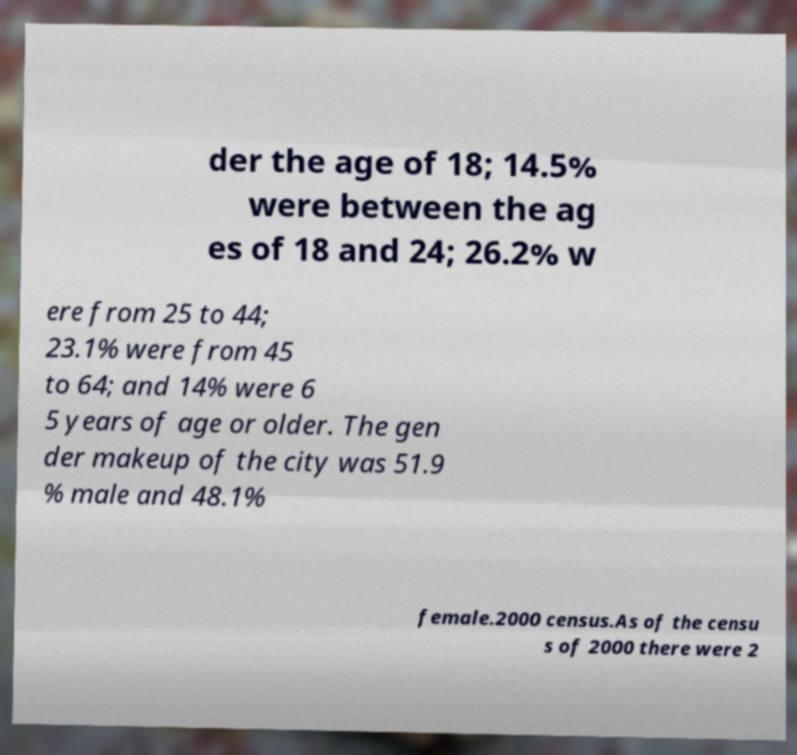What messages or text are displayed in this image? I need them in a readable, typed format. der the age of 18; 14.5% were between the ag es of 18 and 24; 26.2% w ere from 25 to 44; 23.1% were from 45 to 64; and 14% were 6 5 years of age or older. The gen der makeup of the city was 51.9 % male and 48.1% female.2000 census.As of the censu s of 2000 there were 2 